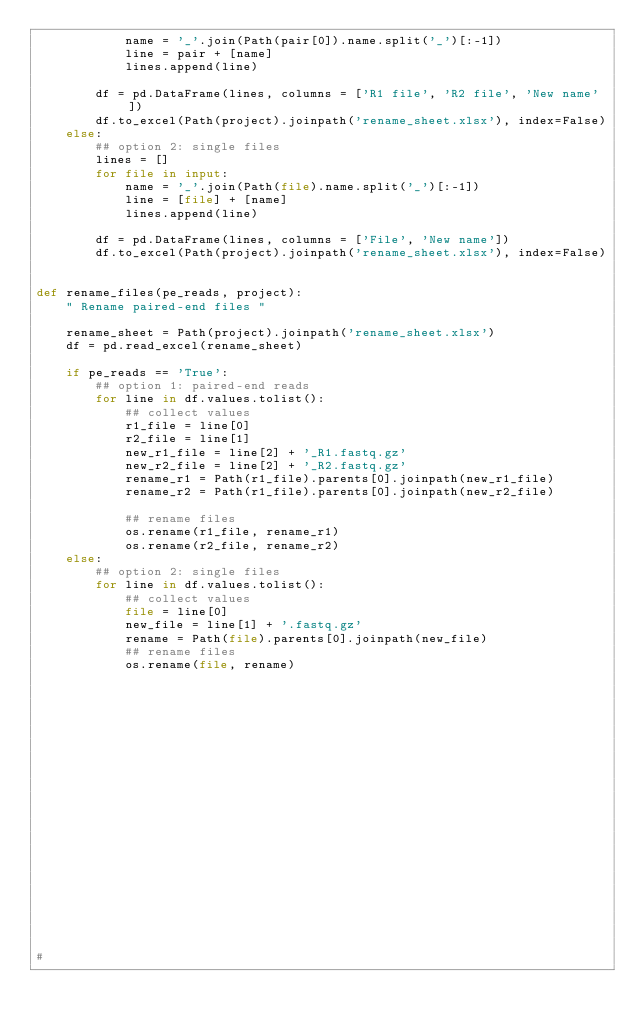Convert code to text. <code><loc_0><loc_0><loc_500><loc_500><_Python_>            name = '_'.join(Path(pair[0]).name.split('_')[:-1])
            line = pair + [name]
            lines.append(line)

        df = pd.DataFrame(lines, columns = ['R1 file', 'R2 file', 'New name'])
        df.to_excel(Path(project).joinpath('rename_sheet.xlsx'), index=False)
    else:
        ## option 2: single files
        lines = []
        for file in input:
            name = '_'.join(Path(file).name.split('_')[:-1])
            line = [file] + [name]
            lines.append(line)

        df = pd.DataFrame(lines, columns = ['File', 'New name'])
        df.to_excel(Path(project).joinpath('rename_sheet.xlsx'), index=False)


def rename_files(pe_reads, project):
    " Rename paired-end files "

    rename_sheet = Path(project).joinpath('rename_sheet.xlsx')
    df = pd.read_excel(rename_sheet)

    if pe_reads == 'True':
        ## option 1: paired-end reads
        for line in df.values.tolist():
            ## collect values
            r1_file = line[0]
            r2_file = line[1]
            new_r1_file = line[2] + '_R1.fastq.gz'
            new_r2_file = line[2] + '_R2.fastq.gz'
            rename_r1 = Path(r1_file).parents[0].joinpath(new_r1_file)
            rename_r2 = Path(r1_file).parents[0].joinpath(new_r2_file)

            ## rename files
            os.rename(r1_file, rename_r1)
            os.rename(r2_file, rename_r2)
    else:
        ## option 2: single files
        for line in df.values.tolist():
            ## collect values
            file = line[0]
            new_file = line[1] + '.fastq.gz'
            rename = Path(file).parents[0].joinpath(new_file)
            ## rename files
            os.rename(file, rename)





















#
</code> 